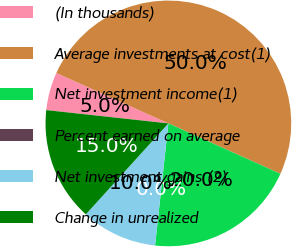Convert chart. <chart><loc_0><loc_0><loc_500><loc_500><pie_chart><fcel>(In thousands)<fcel>Average investments at cost(1)<fcel>Net investment income(1)<fcel>Percent earned on average<fcel>Net investment gains (2)<fcel>Change in unrealized<nl><fcel>5.0%<fcel>50.0%<fcel>20.0%<fcel>0.0%<fcel>10.0%<fcel>15.0%<nl></chart> 